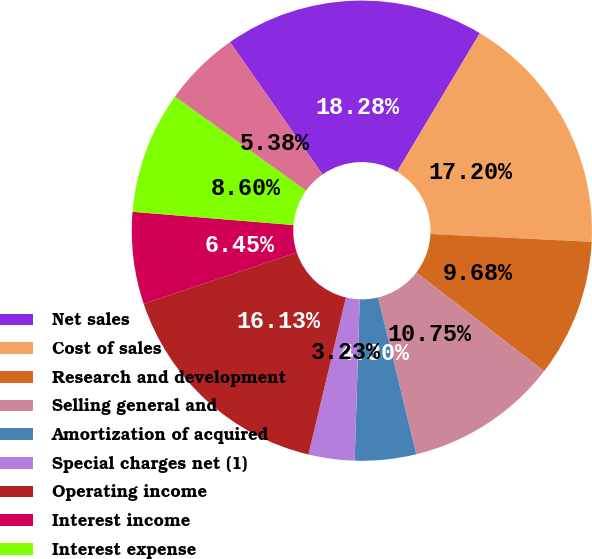Convert chart to OTSL. <chart><loc_0><loc_0><loc_500><loc_500><pie_chart><fcel>Net sales<fcel>Cost of sales<fcel>Research and development<fcel>Selling general and<fcel>Amortization of acquired<fcel>Special charges net (1)<fcel>Operating income<fcel>Interest income<fcel>Interest expense<fcel>Other (expense) income net<nl><fcel>18.28%<fcel>17.2%<fcel>9.68%<fcel>10.75%<fcel>4.3%<fcel>3.23%<fcel>16.13%<fcel>6.45%<fcel>8.6%<fcel>5.38%<nl></chart> 